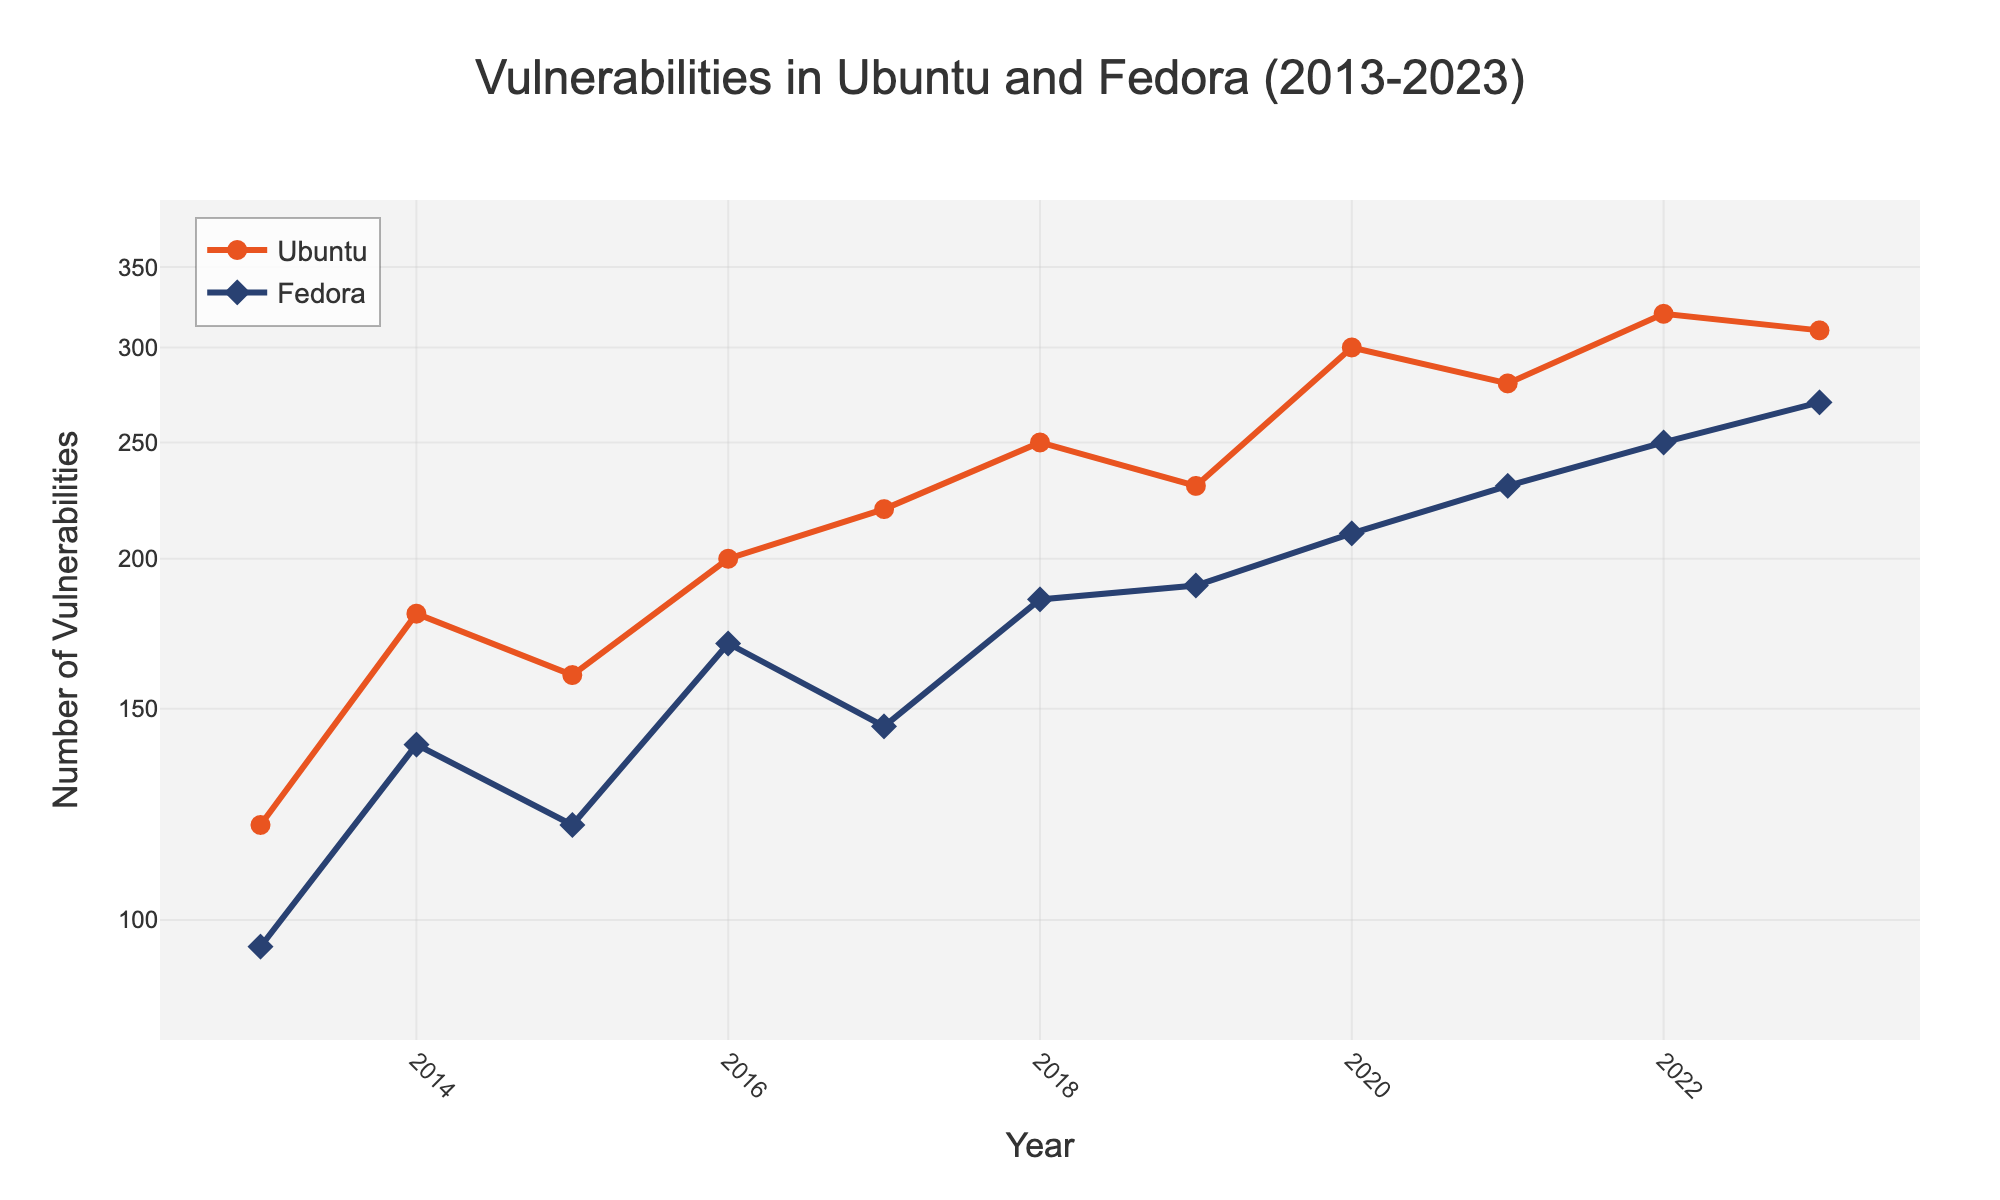What's the number of vulnerabilities found in Ubuntu in 2020? Look for the data point representing Ubuntu in 2020 on the figure. The y-axis will provide the number of vulnerabilities.
Answer: 300 What's the difference in the number of vulnerabilities between Fedora and Ubuntu in 2021? Compare the data points for Fedora and Ubuntu in 2021 on the figure and subtract the number of vulnerabilities found in Fedora from those found in Ubuntu.
Answer: 50 Which distribution had more vulnerabilities in 2018, and by how much? Compare the data points for Fedora and Ubuntu in 2018. Subtract the number of vulnerabilities in Fedora from those in Ubuntu.
Answer: Ubuntu by 65 How did the number of vulnerabilities in Ubuntu change from 2013 to 2022? Compare the data points for Ubuntu in 2013 and 2022 on the figure. Calculate the difference between them.
Answer: Increased by 200 Between which years did Fedora see the largest increase in vulnerabilities? Look at the data points for Fedora and identify the two consecutive years where the increase in the number of vulnerabilities is the largest.
Answer: 2021-2022 On average, how many vulnerabilities were found per year in Fedora from 2013 to 2023? Sum all the vulnerabilities for Fedora from 2013 to 2023 and divide by the number of years (11).
Answer: 172.27 Which version of Ubuntu had the highest number of vulnerabilities? Identify the highest data point for Ubuntu and refer to the corresponding version number.
Answer: 22.04 LTS How did the trend in vulnerabilities for Fedora compare to Ubuntu over the decade? Observe the general trends for each distribution on the figure to determine if vulnerabilities increased, decreased, or stayed stable.
Answer: Both increased, but Ubuntu had a steeper increase What was the log scale range used for the y-axis in the plot? Examine the y-axis labels and grid lines to determine the range of the logarithmic scale used.
Answer: 1.9 to 2.6 How many data points are there for Ubuntu in the entire plot? Count the number of data points (i.e., marker symbols) specifically for Ubuntu throughout the figure.
Answer: 10 